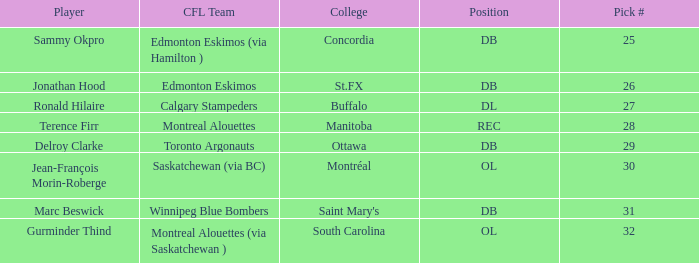What is buffalo's pick #? 27.0. 